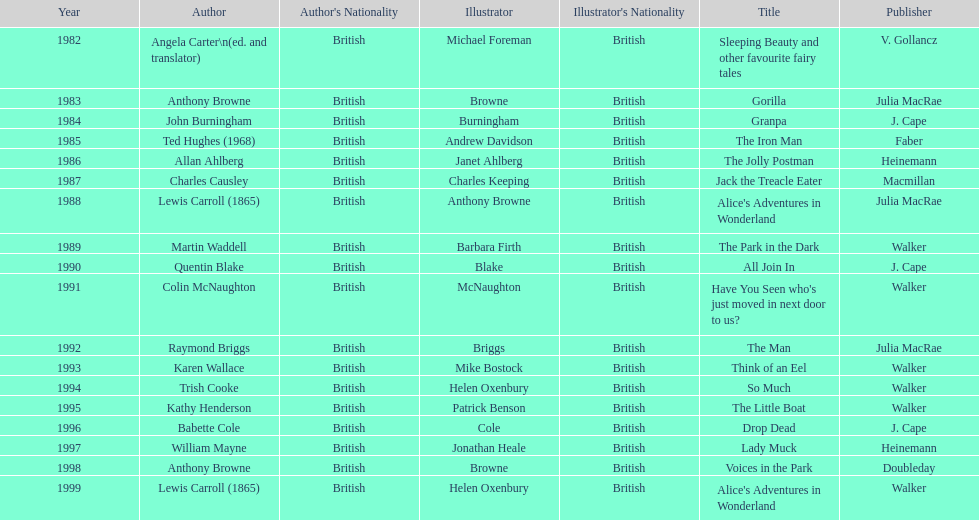Write the full table. {'header': ['Year', 'Author', "Author's Nationality", 'Illustrator', "Illustrator's Nationality", 'Title', 'Publisher'], 'rows': [['1982', 'Angela Carter\\n(ed. and translator)', 'British', 'Michael Foreman', 'British', 'Sleeping Beauty and other favourite fairy tales', 'V. Gollancz'], ['1983', 'Anthony Browne', 'British', 'Browne', 'British', 'Gorilla', 'Julia MacRae'], ['1984', 'John Burningham', 'British', 'Burningham', 'British', 'Granpa', 'J. Cape'], ['1985', 'Ted Hughes (1968)', 'British', 'Andrew Davidson', 'British', 'The Iron Man', 'Faber'], ['1986', 'Allan Ahlberg', 'British', 'Janet Ahlberg', 'British', 'The Jolly Postman', 'Heinemann'], ['1987', 'Charles Causley', 'British', 'Charles Keeping', 'British', 'Jack the Treacle Eater', 'Macmillan'], ['1988', 'Lewis Carroll (1865)', 'British', 'Anthony Browne', 'British', "Alice's Adventures in Wonderland", 'Julia MacRae'], ['1989', 'Martin Waddell', 'British', 'Barbara Firth', 'British', 'The Park in the Dark', 'Walker'], ['1990', 'Quentin Blake', 'British', 'Blake', 'British', 'All Join In', 'J. Cape'], ['1991', 'Colin McNaughton', 'British', 'McNaughton', 'British', "Have You Seen who's just moved in next door to us?", 'Walker'], ['1992', 'Raymond Briggs', 'British', 'Briggs', 'British', 'The Man', 'Julia MacRae'], ['1993', 'Karen Wallace', 'British', 'Mike Bostock', 'British', 'Think of an Eel', 'Walker'], ['1994', 'Trish Cooke', 'British', 'Helen Oxenbury', 'British', 'So Much', 'Walker'], ['1995', 'Kathy Henderson', 'British', 'Patrick Benson', 'British', 'The Little Boat', 'Walker'], ['1996', 'Babette Cole', 'British', 'Cole', 'British', 'Drop Dead', 'J. Cape'], ['1997', 'William Mayne', 'British', 'Jonathan Heale', 'British', 'Lady Muck', 'Heinemann'], ['1998', 'Anthony Browne', 'British', 'Browne', 'British', 'Voices in the Park', 'Doubleday'], ['1999', 'Lewis Carroll (1865)', 'British', 'Helen Oxenbury', 'British', "Alice's Adventures in Wonderland", 'Walker']]} How many titles had the same author listed as the illustrator? 7. 